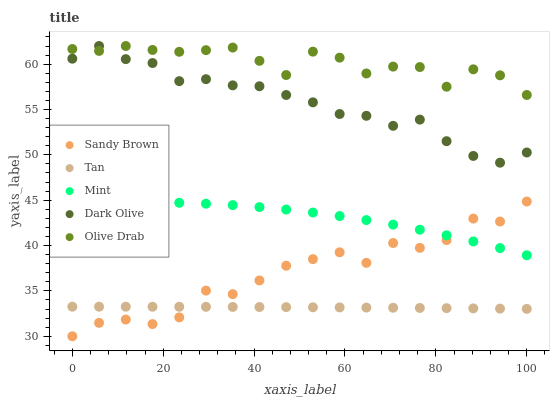Does Tan have the minimum area under the curve?
Answer yes or no. Yes. Does Olive Drab have the maximum area under the curve?
Answer yes or no. Yes. Does Dark Olive have the minimum area under the curve?
Answer yes or no. No. Does Dark Olive have the maximum area under the curve?
Answer yes or no. No. Is Tan the smoothest?
Answer yes or no. Yes. Is Sandy Brown the roughest?
Answer yes or no. Yes. Is Dark Olive the smoothest?
Answer yes or no. No. Is Dark Olive the roughest?
Answer yes or no. No. Does Sandy Brown have the lowest value?
Answer yes or no. Yes. Does Tan have the lowest value?
Answer yes or no. No. Does Olive Drab have the highest value?
Answer yes or no. Yes. Does Tan have the highest value?
Answer yes or no. No. Is Tan less than Dark Olive?
Answer yes or no. Yes. Is Mint greater than Tan?
Answer yes or no. Yes. Does Sandy Brown intersect Mint?
Answer yes or no. Yes. Is Sandy Brown less than Mint?
Answer yes or no. No. Is Sandy Brown greater than Mint?
Answer yes or no. No. Does Tan intersect Dark Olive?
Answer yes or no. No. 